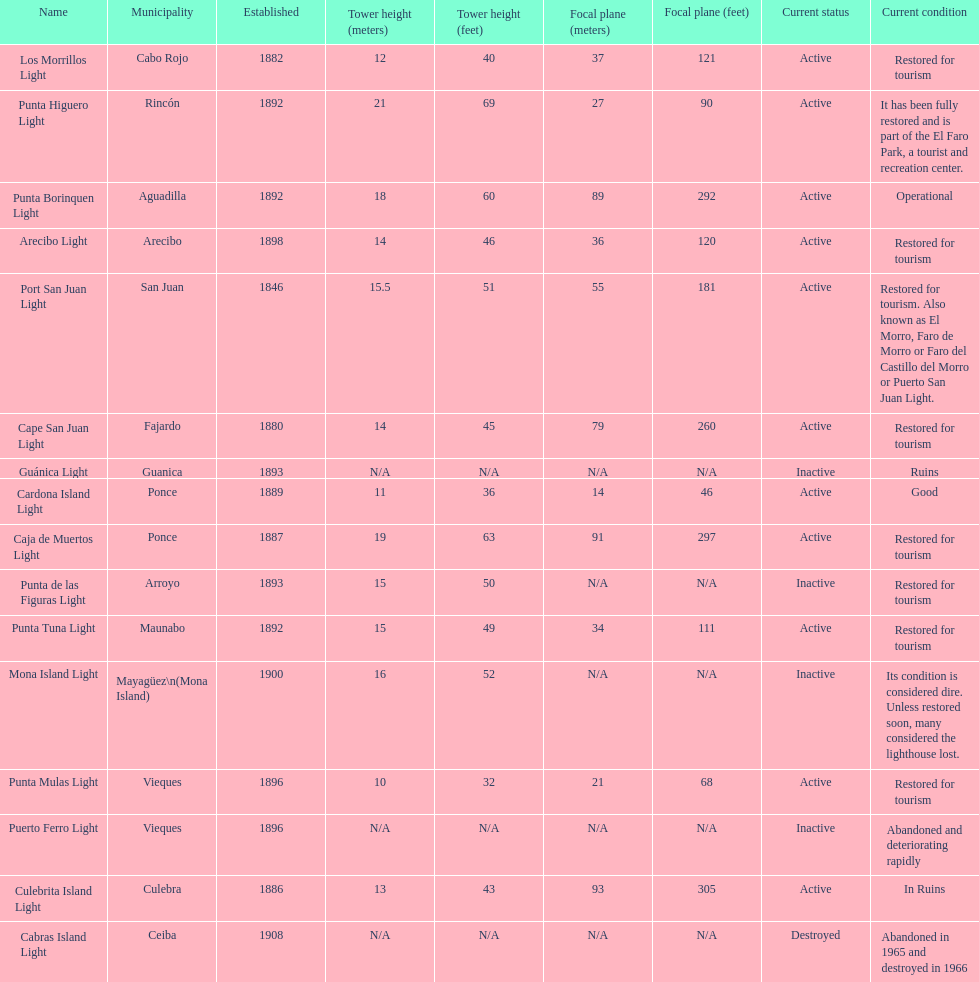Number of lighthouses that begin with the letter p 7. 